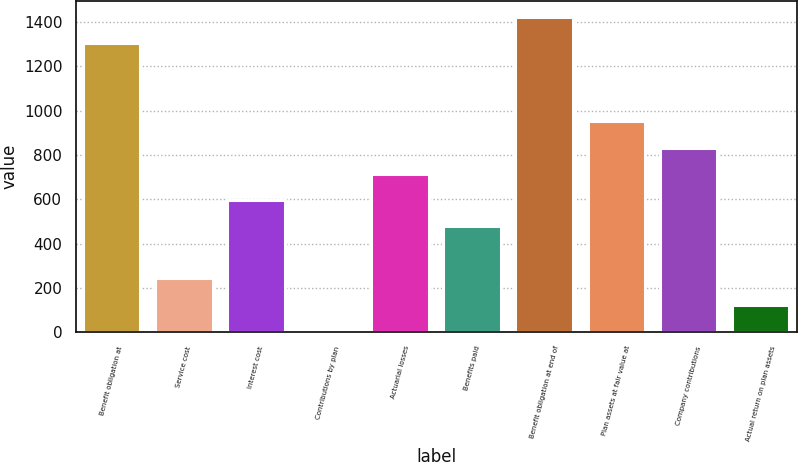Convert chart to OTSL. <chart><loc_0><loc_0><loc_500><loc_500><bar_chart><fcel>Benefit obligation at<fcel>Service cost<fcel>Interest cost<fcel>Contributions by plan<fcel>Actuarial losses<fcel>Benefits paid<fcel>Benefit obligation at end of<fcel>Plan assets at fair value at<fcel>Company contributions<fcel>Actual return on plan assets<nl><fcel>1306.2<fcel>242.4<fcel>597<fcel>6<fcel>715.2<fcel>478.8<fcel>1424.4<fcel>951.6<fcel>833.4<fcel>124.2<nl></chart> 